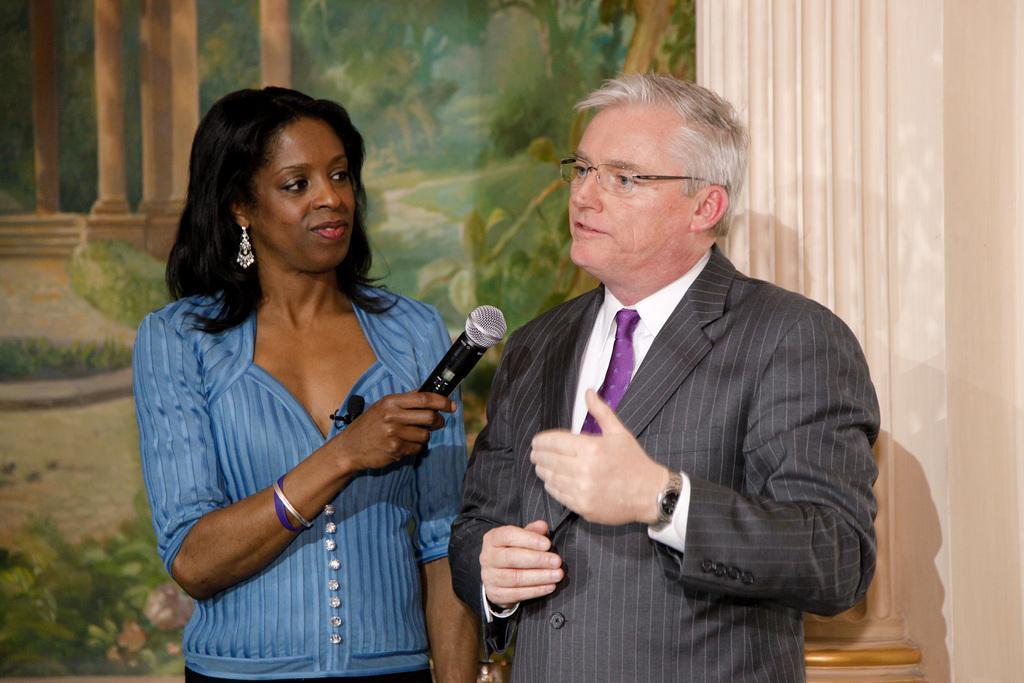Can you describe this image briefly? In this image in the middle there is a man he wears suit, tie, shirt and watch he is speaking. On the left there is a woman she wear blue dress her hair is short she is holding a mic. In the background there is a pillar, poster and wall. 